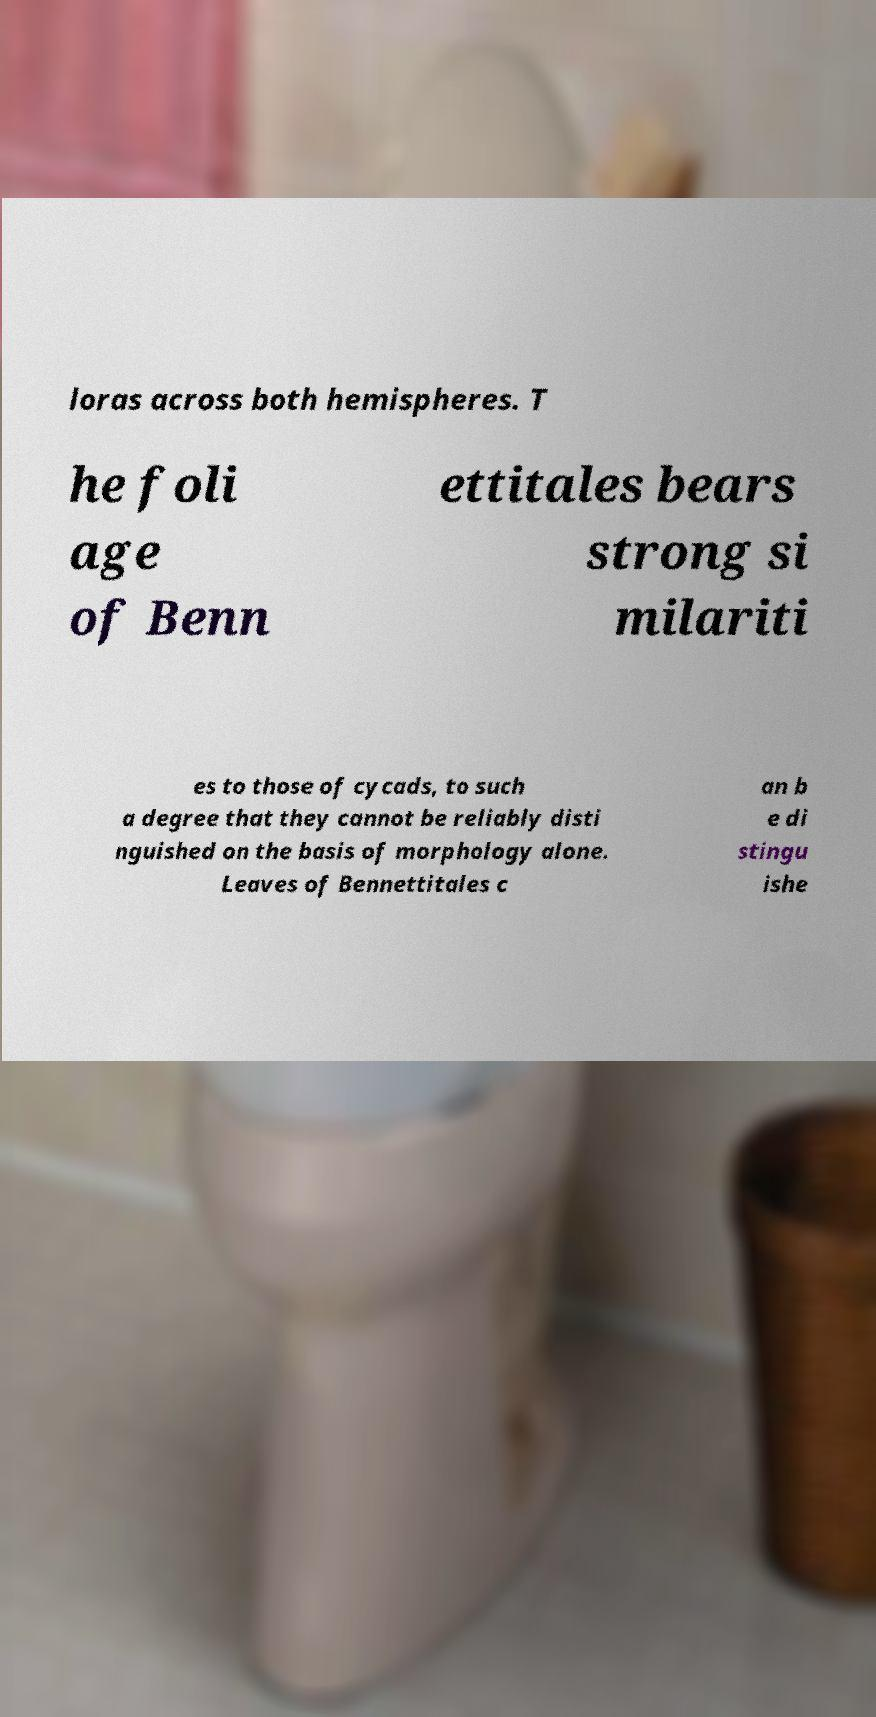Please identify and transcribe the text found in this image. loras across both hemispheres. T he foli age of Benn ettitales bears strong si milariti es to those of cycads, to such a degree that they cannot be reliably disti nguished on the basis of morphology alone. Leaves of Bennettitales c an b e di stingu ishe 